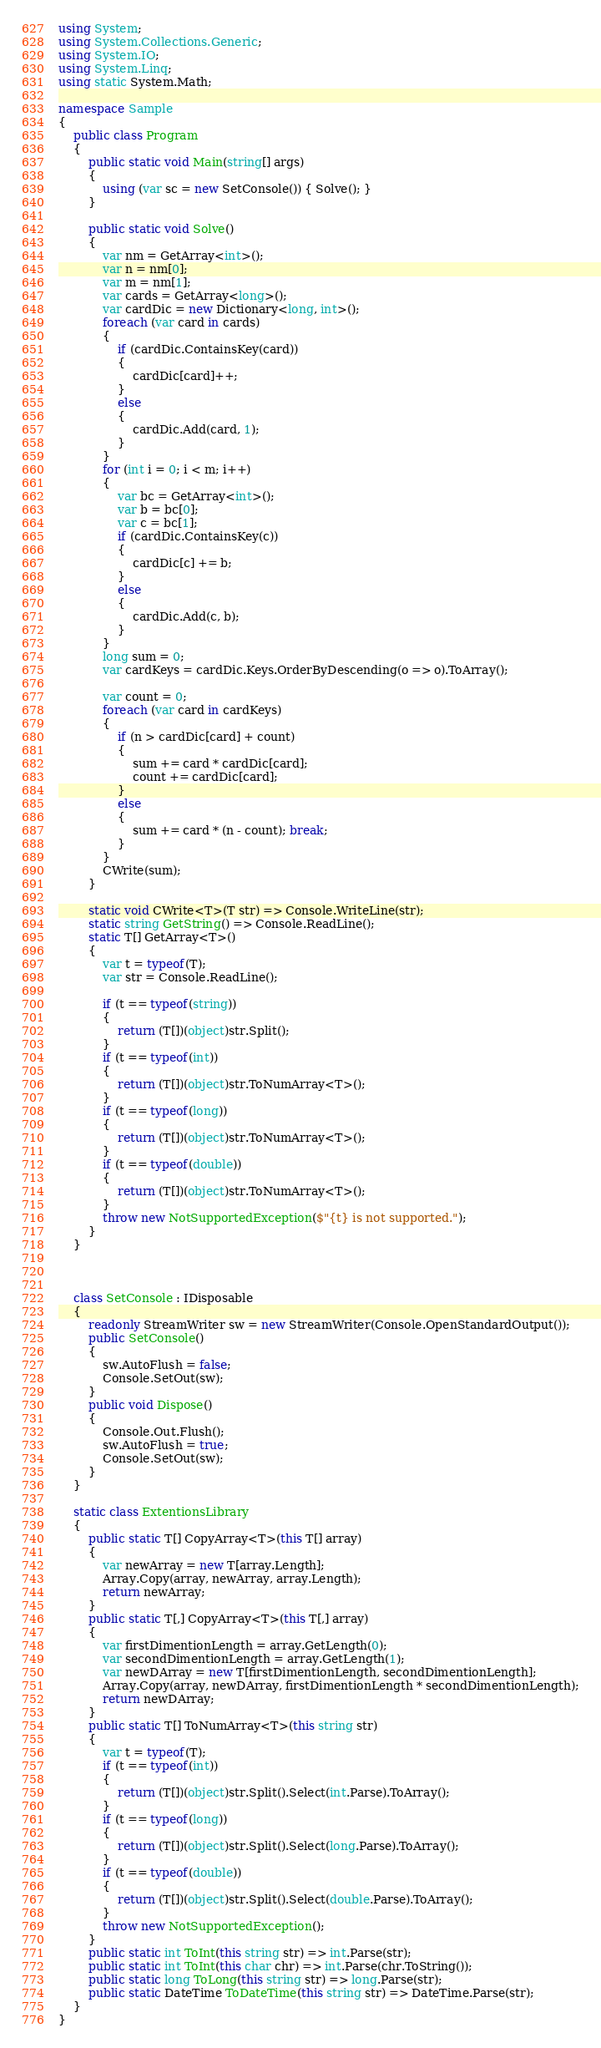Convert code to text. <code><loc_0><loc_0><loc_500><loc_500><_C#_>using System;
using System.Collections.Generic;
using System.IO;
using System.Linq;
using static System.Math;

namespace Sample
{
    public class Program
    {
        public static void Main(string[] args)
        {
            using (var sc = new SetConsole()) { Solve(); }
        }

        public static void Solve()
        {
            var nm = GetArray<int>();
            var n = nm[0];
            var m = nm[1];
            var cards = GetArray<long>();
            var cardDic = new Dictionary<long, int>();
            foreach (var card in cards)
            {
                if (cardDic.ContainsKey(card))
                {
                    cardDic[card]++;
                }
                else
                {
                    cardDic.Add(card, 1);
                }
            }
            for (int i = 0; i < m; i++)
            {
                var bc = GetArray<int>();
                var b = bc[0];
                var c = bc[1];
                if (cardDic.ContainsKey(c))
                {
                    cardDic[c] += b;
                }
                else
                {
                    cardDic.Add(c, b);
                }
            }
            long sum = 0;
            var cardKeys = cardDic.Keys.OrderByDescending(o => o).ToArray();

            var count = 0;
            foreach (var card in cardKeys)
            {
                if (n > cardDic[card] + count)
                {
                    sum += card * cardDic[card];
                    count += cardDic[card];
                }
                else
                {
                    sum += card * (n - count); break;
                }
            }
            CWrite(sum);
        }

        static void CWrite<T>(T str) => Console.WriteLine(str);
        static string GetString() => Console.ReadLine();
        static T[] GetArray<T>()
        {
            var t = typeof(T);
            var str = Console.ReadLine();

            if (t == typeof(string))
            {
                return (T[])(object)str.Split();
            }
            if (t == typeof(int))
            {
                return (T[])(object)str.ToNumArray<T>();
            }
            if (t == typeof(long))
            {
                return (T[])(object)str.ToNumArray<T>();
            }
            if (t == typeof(double))
            {
                return (T[])(object)str.ToNumArray<T>();
            }
            throw new NotSupportedException($"{t} is not supported.");
        }
    }



    class SetConsole : IDisposable
    {
        readonly StreamWriter sw = new StreamWriter(Console.OpenStandardOutput());
        public SetConsole()
        {
            sw.AutoFlush = false;
            Console.SetOut(sw);
        }
        public void Dispose()
        {
            Console.Out.Flush();
            sw.AutoFlush = true;
            Console.SetOut(sw);
        }
    }

    static class ExtentionsLibrary
    {
        public static T[] CopyArray<T>(this T[] array)
        {
            var newArray = new T[array.Length];
            Array.Copy(array, newArray, array.Length);
            return newArray;
        }
        public static T[,] CopyArray<T>(this T[,] array)
        {
            var firstDimentionLength = array.GetLength(0);
            var secondDimentionLength = array.GetLength(1);
            var newDArray = new T[firstDimentionLength, secondDimentionLength];
            Array.Copy(array, newDArray, firstDimentionLength * secondDimentionLength);
            return newDArray;
        }
        public static T[] ToNumArray<T>(this string str)
        {
            var t = typeof(T);
            if (t == typeof(int))
            {
                return (T[])(object)str.Split().Select(int.Parse).ToArray();
            }
            if (t == typeof(long))
            {
                return (T[])(object)str.Split().Select(long.Parse).ToArray();
            }
            if (t == typeof(double))
            {
                return (T[])(object)str.Split().Select(double.Parse).ToArray();
            }
            throw new NotSupportedException();
        }
        public static int ToInt(this string str) => int.Parse(str);
        public static int ToInt(this char chr) => int.Parse(chr.ToString());
        public static long ToLong(this string str) => long.Parse(str);
        public static DateTime ToDateTime(this string str) => DateTime.Parse(str);
    }
}
</code> 